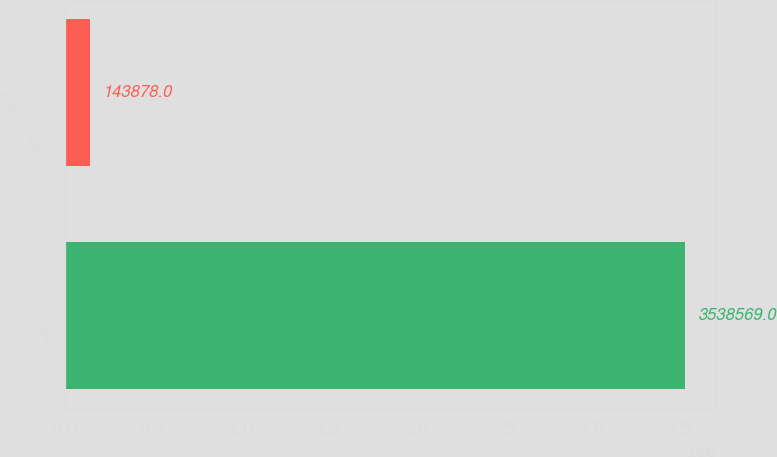Convert chart. <chart><loc_0><loc_0><loc_500><loc_500><bar_chart><fcel>Goodwill<fcel>Intangible assets with<nl><fcel>3.53857e+06<fcel>143878<nl></chart> 